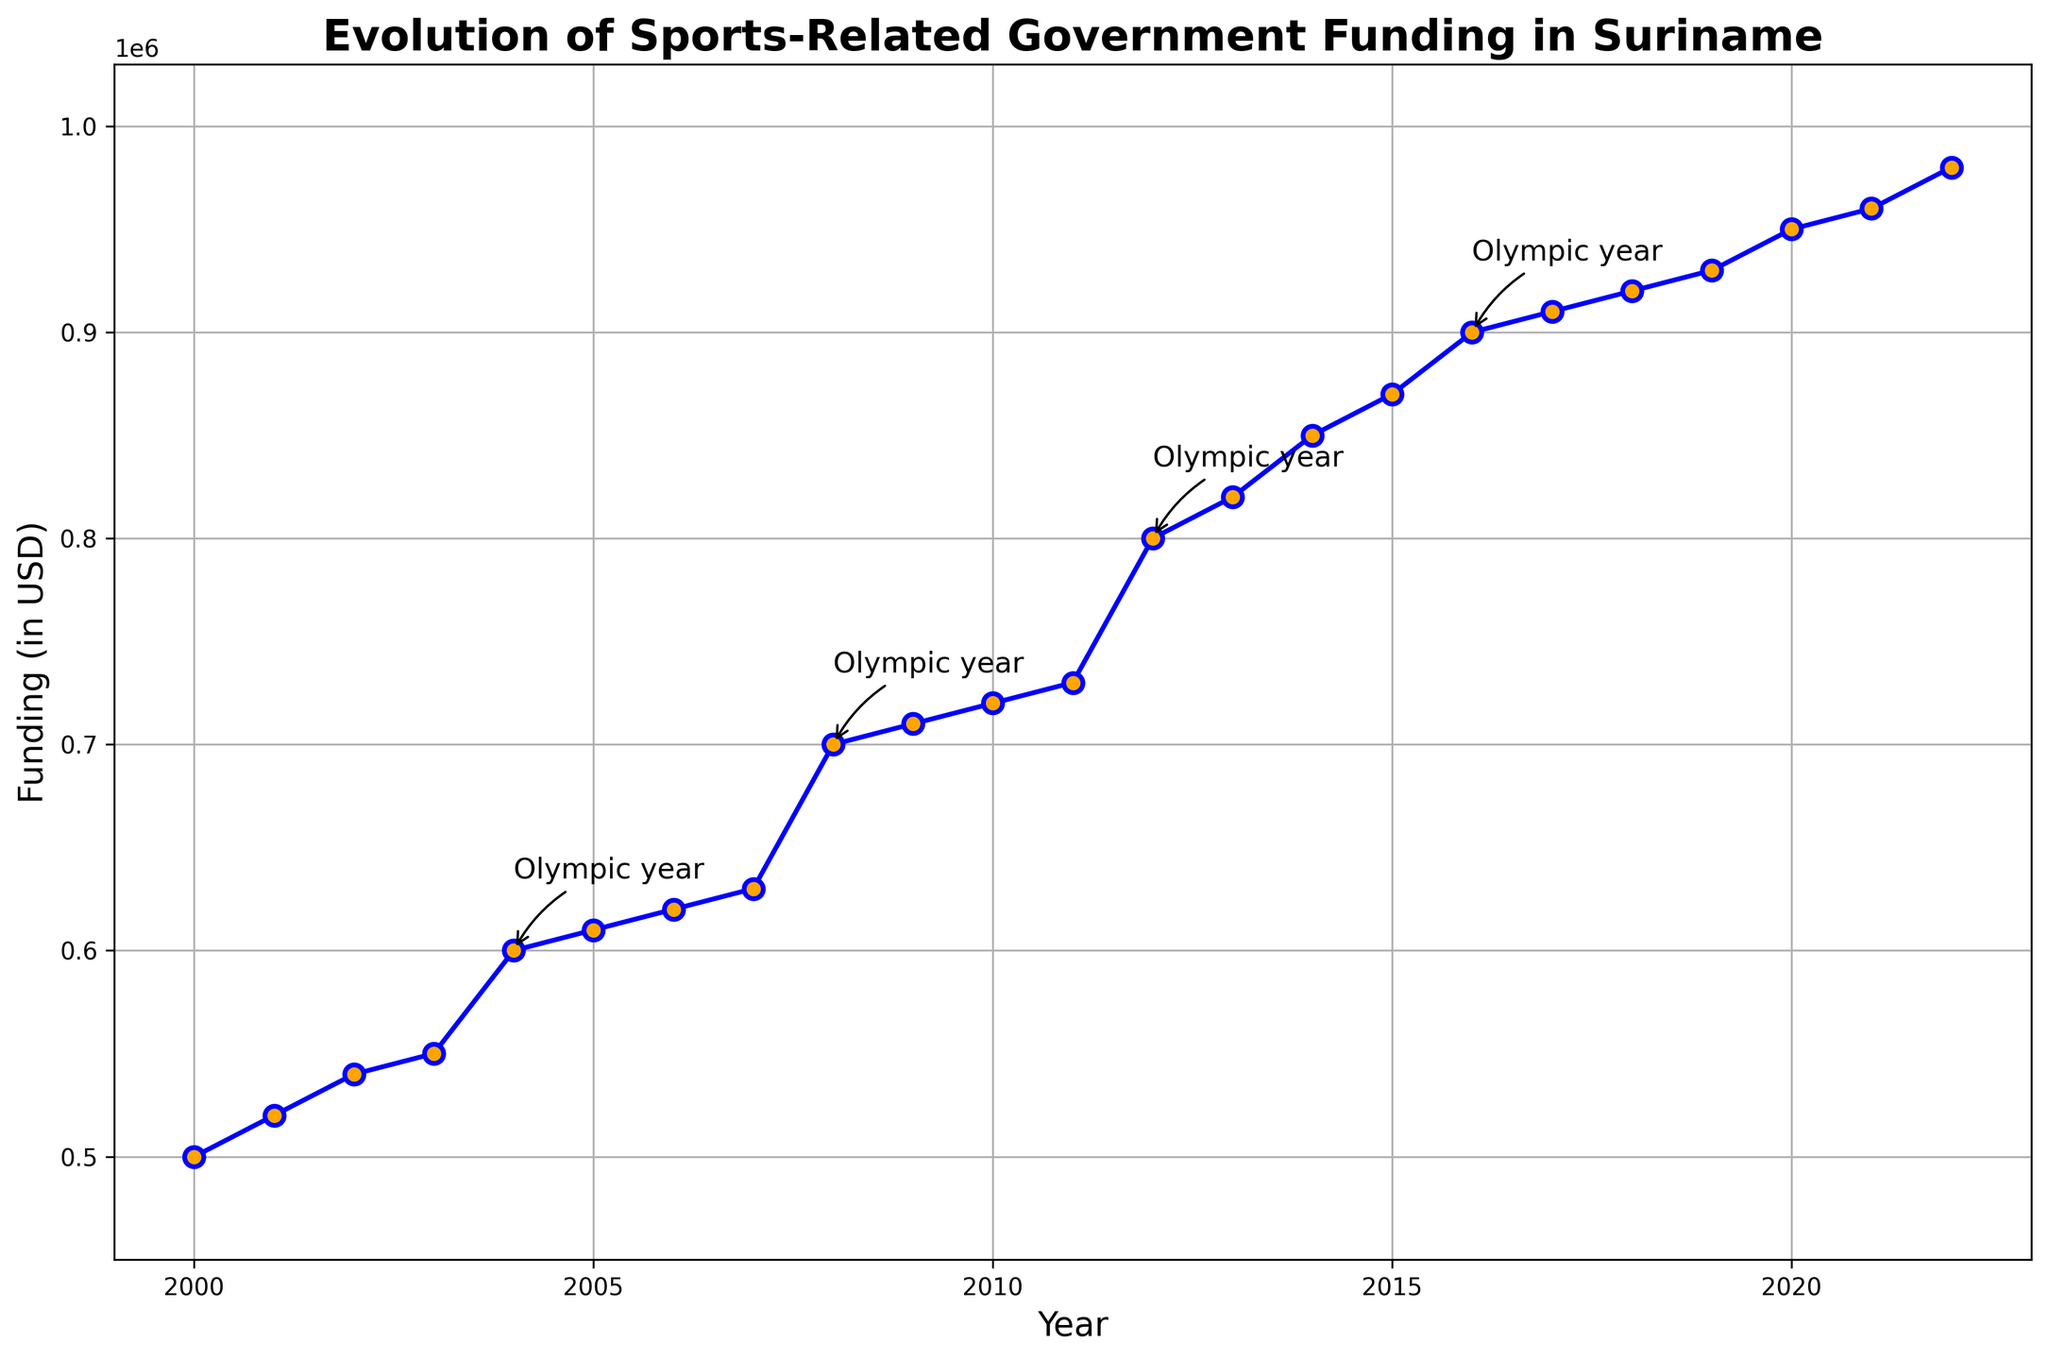What pattern do you notice in the funding amounts during Olympic years? During every Olympic year (2004, 2008, 2012, 2016), there is a noticeable boost in funding compared to the previous year. For example, funding increased from $550,000 in 2003 to $600,000 in 2004, from $630,000 in 2007 to $700,000 in 2008, and similar patterns can be seen in subsequent Olympic years.
Answer: Increased funding during Olympic years What is the difference in funding between 2004 and 2005? In 2004, the funding was $600,000 and in 2005 it was $610,000. The difference is $610,000 - $600,000.
Answer: $10,000 In which year was the funding first recorded as exceeding $900,000? The funding first exceeded $900,000 in the year 2016 with a value of $900,000.
Answer: 2016 What is the average funding for the years 2000 and 2022? The funding in 2000 was $500,000 and in 2022 it was $980,000. The average is calculated as ($500,000 + $980,000) / 2.
Answer: $740,000 Which year had the highest funding, and how much was it? The highest funding was in the year 2022, with an amount of $980,000.
Answer: 2022 with $980,000 Compare the funding trend before and after 2008. What changes do you notice? Before 2008, the funding increased gradually from $500,000 in 2000 to $630,000 in 2007. After 2008, the funding shows steeper increases, for example, from $700,000 in 2008 to $800,000 in 2012 and eventually to $980,000 in 2022.
Answer: Steeper increases after 2008 How much did the funding increase from 2011 to 2012? In 2011, the funding was $730,000, whereas in 2012, it was $800,000. The increase is $800,000 - $730,000.
Answer: $70,000 Identify the years with annotations and describe their significance based on the visual attributes of the figure. The annotated years are 2004, 2008, 2012, and 2016, all marked as Olympic years. These annotations highlight that during these years, there is a noticeable increase in funding compared to other years, indicating a post-Olympic boost in sports-related government funding.
Answer: 2004, 2008, 2012, and 2016 are Olympic years with increased funding What is the total funding increment observed from 2000 to 2022? The funding in 2000 was $500,000, and in 2022 it was $980,000. The increment is calculated as $980,000 - $500,000.
Answer: $480,000 